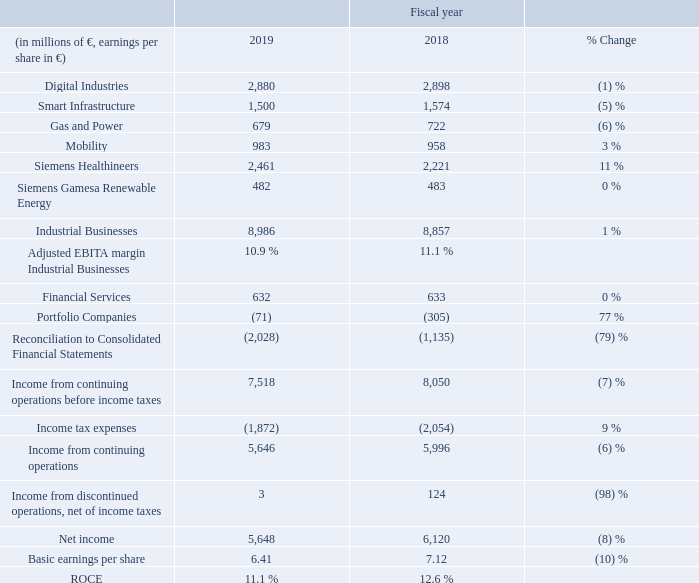A.4.2 Income
As a result of the development described for the segments, Income from continuing operations before income taxes declined 7 %. Severance charges for continuing operations were € 619 million, of which € 492 million were in Industrial Businesses. Accordingly, Adjusted EBITA margin Industrial Businesses excluding severance charges was 11.5 % in fiscal 2019. In fiscal 2018, severance charges for continuing operations were € 923 million, of which € 669 million were in Industrial Businesses.
The tax rate of 25% for fiscal 2019 was below the tax rate of 26% for the prior year, benefiting mainly from the reversal of income tax provisions outside Germany. As a result, Income from continuing operations declined 6%.
Income from discontinued operations, net of income taxes in the prior year included positive effects from the release of a provision related to former Communications activities.
The decline in basic earnings per share reflects the decrease of Net income attributable to Shareholders of Siemens AG, which was € 5,174 million in fiscal 2019 compared to € 5,807 million in fiscal 2018, partially offset by a lower number of weighted average shares outstanding. Basic earnings per share excluding severance charges was € 6.93.
As expected, ROCE at 11.1 % was below the target range set in our Siemens Financial Framework, reflecting in particular the effects from portfolio transactions in recent years, including the acquisitions of Mentor and Mendix at Digital Industries and the merger of Siemens’ wind power business with Gamesa Corporación Tecnológica, S. A. that created SGRE. The decline year-over-year was due both to lower income before interest after tax and to higher average capital employed.
What was the impact of development described for the segments? As a result of the development described for the segments, income from continuing operations before income taxes declined 7 %. What was the tax rate in 2019? 25%. What do the decline in basic earnings per share represent? The decline in basic earnings per share reflects the decrease of net income attributable to shareholders of siemens ag, which was € 5,174 million in fiscal 2019 compared to € 5,807 million in fiscal 2018, partially offset by a lower number of weighted average shares outstanding. basic earnings per share excluding severance charges was € 6.93. What was the average of digital industries in 2019 and 2018?
Answer scale should be: million. (2,880 + 2,898) / 2
Answer: 2889. What is the increase / (decrease) in the Gas and Power from 2018 to 2019?
Answer scale should be: million. 679 - 722
Answer: -43. What is the increase / (decrease) in ROCE from 2018 to 2019?
Answer scale should be: percent. 11.1% - 12.6%
Answer: -1.5. 